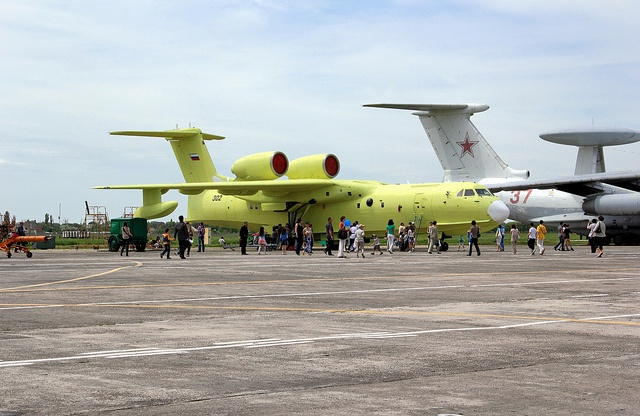Describe the objects in this image and their specific colors. I can see airplane in lavender, olive, and khaki tones, airplane in lavender, darkgray, gray, lightgray, and black tones, people in lavender, black, darkgreen, darkgray, and gray tones, people in lavender, gray, darkgreen, black, and darkgray tones, and people in lavender, black, gray, and darkgray tones in this image. 